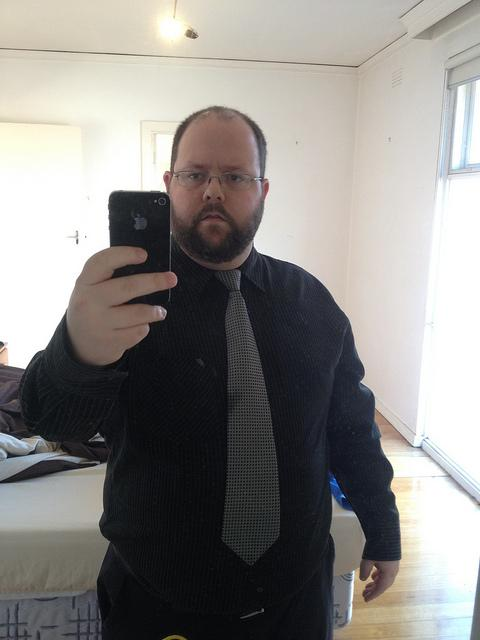What is the man taking? Please explain your reasoning. selfie. He's holding the phone up in front of his face 